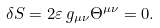<formula> <loc_0><loc_0><loc_500><loc_500>\delta S = 2 \varepsilon \, g _ { \mu \nu } \Theta ^ { \mu \nu } = 0 .</formula> 